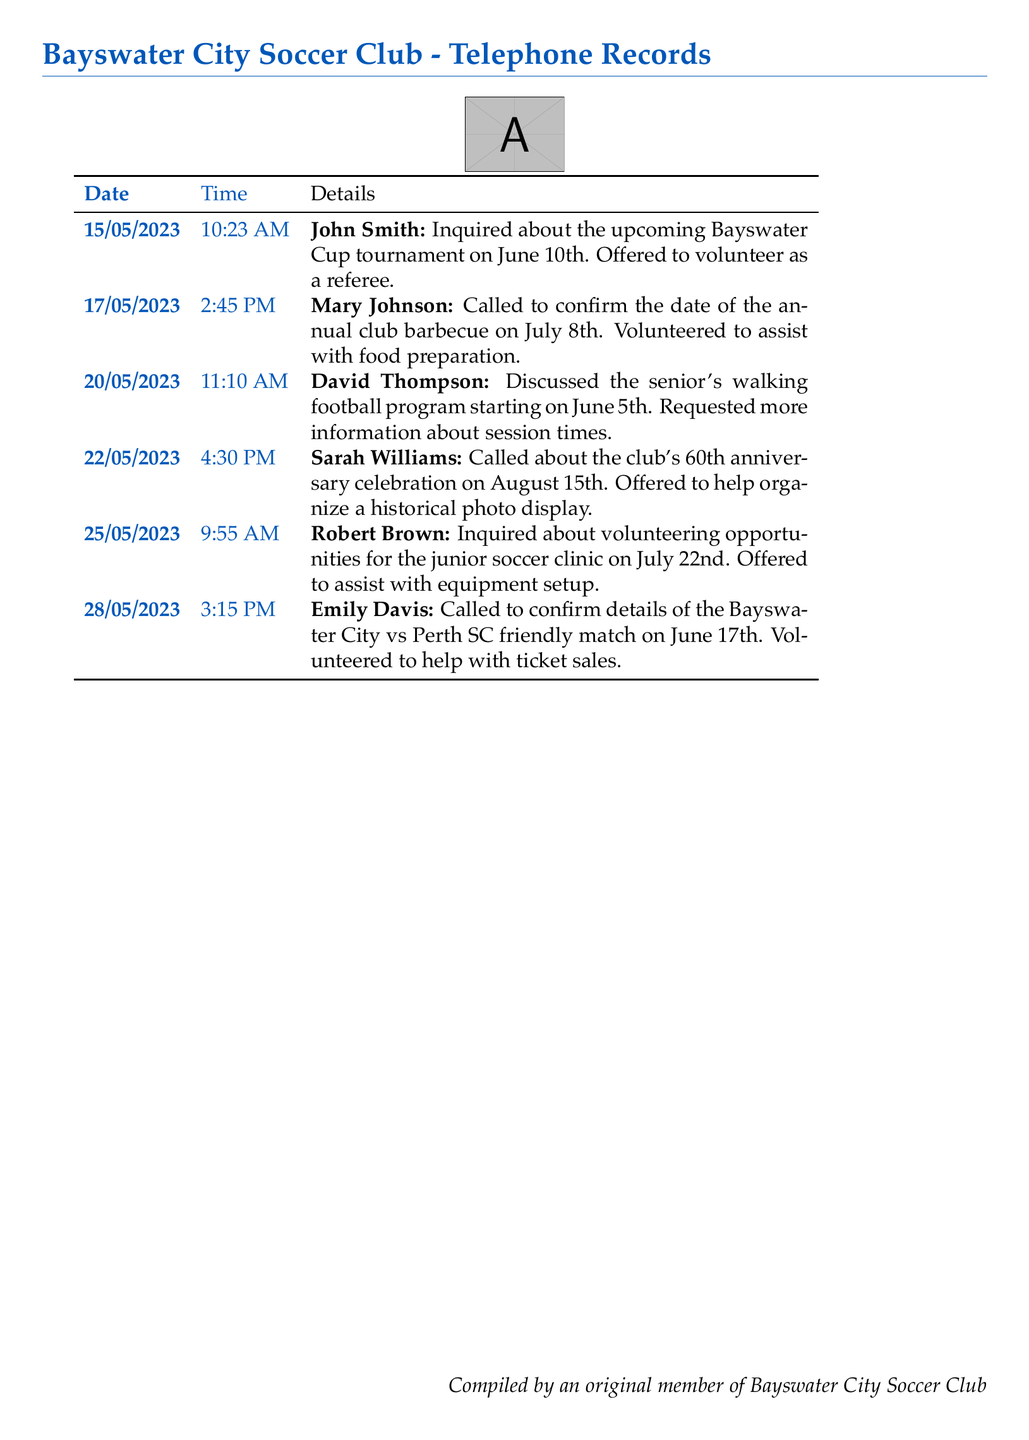What date is the Bayswater Cup tournament? The date of the Bayswater Cup tournament is mentioned in the call details, which is June 10th.
Answer: June 10th Who offered to help with the food preparation for the barbecue? Mary Johnson confirmed the date of the barbecue and said she would assist with food preparation.
Answer: Mary Johnson What is the focus of the program starting on June 5th? The document mentions a senior's walking football program, indicating that it is meant for seniors.
Answer: Senior's walking football What event is scheduled for August 15th? The call details refer to the club's 60th anniversary celebration taking place on this date.
Answer: 60th anniversary celebration Which volunteer opportunity is associated with the date July 22nd? The document states Robert Brown inquired about volunteering for the junior soccer clinic on this date.
Answer: Junior soccer clinic How many people volunteered to help with ticket sales? Emily Davis is the only person mentioned who volunteered for ticket sales, indicating one volunteer for this task.
Answer: One Which call discussed a friendly match? The document indicates that the call to confirm details about the Bayswater City vs Perth SC friendly match was made by Emily Davis.
Answer: Emily Davis What time did John Smith call the club office? The time of John Smith's call is recorded as 10:23 AM in the document.
Answer: 10:23 AM What activity is being organized for the June 17th match? The call detail shows that there is a need for assistance with ticket sales for the friendly match on this date.
Answer: Ticket sales 